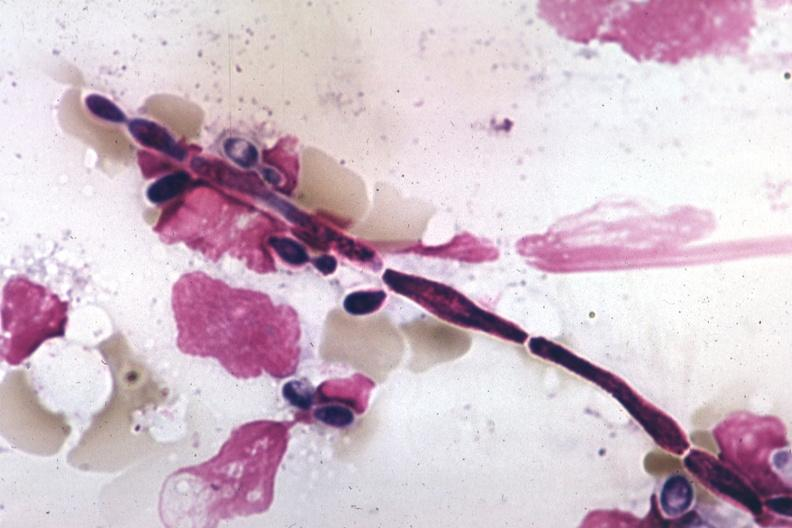does this image show pseudohyphal forms?
Answer the question using a single word or phrase. Yes 